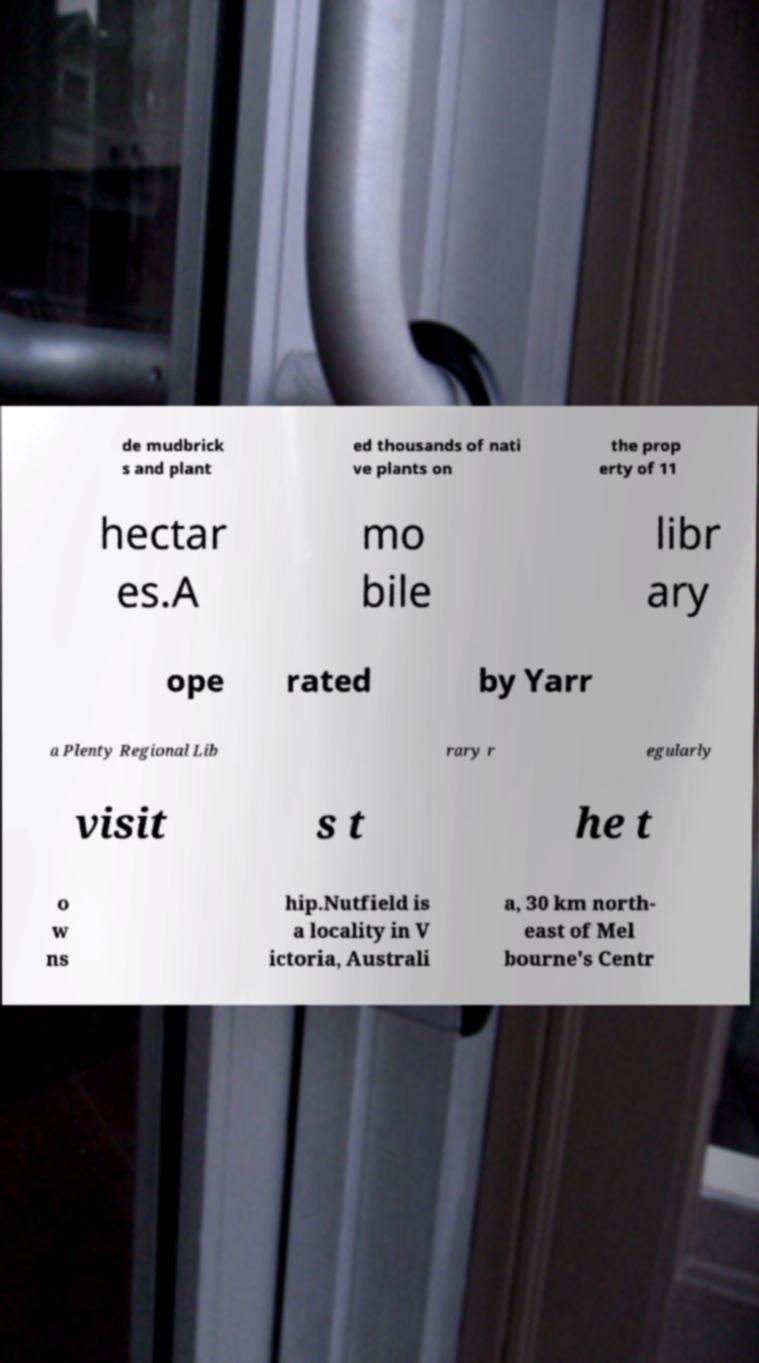Could you extract and type out the text from this image? de mudbrick s and plant ed thousands of nati ve plants on the prop erty of 11 hectar es.A mo bile libr ary ope rated by Yarr a Plenty Regional Lib rary r egularly visit s t he t o w ns hip.Nutfield is a locality in V ictoria, Australi a, 30 km north- east of Mel bourne's Centr 